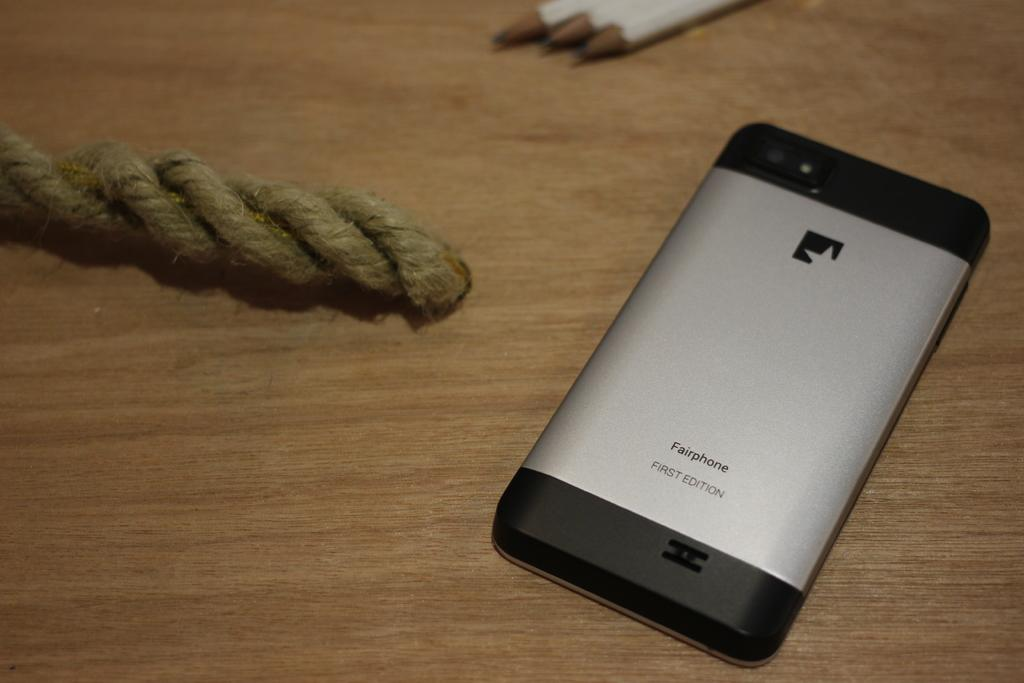<image>
Describe the image concisely. A piece of rope and white pencils are on a table next to a face down Fairphone. 